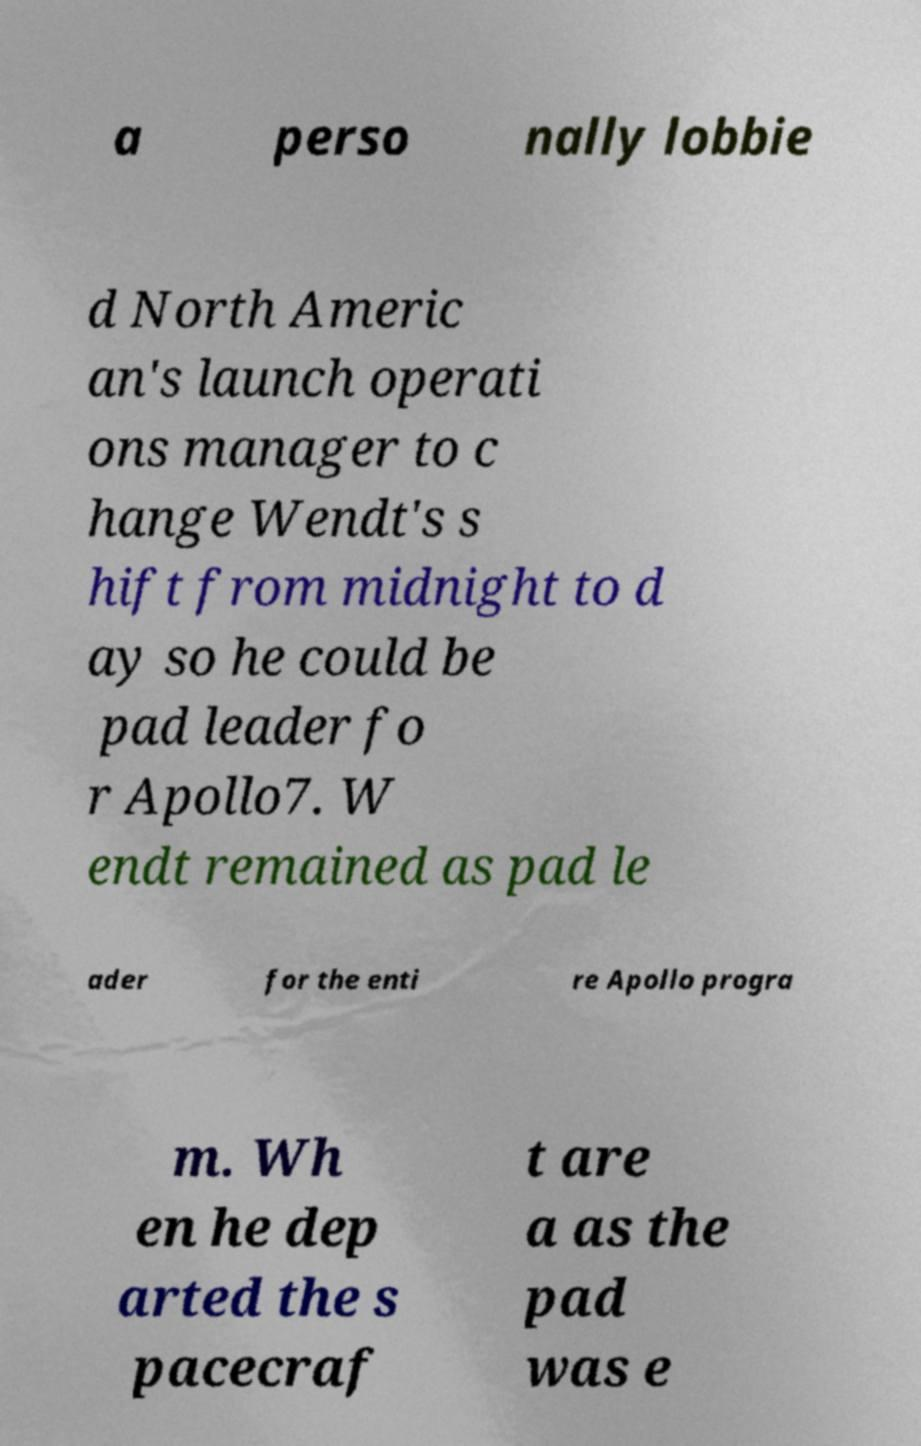Please identify and transcribe the text found in this image. a perso nally lobbie d North Americ an's launch operati ons manager to c hange Wendt's s hift from midnight to d ay so he could be pad leader fo r Apollo7. W endt remained as pad le ader for the enti re Apollo progra m. Wh en he dep arted the s pacecraf t are a as the pad was e 